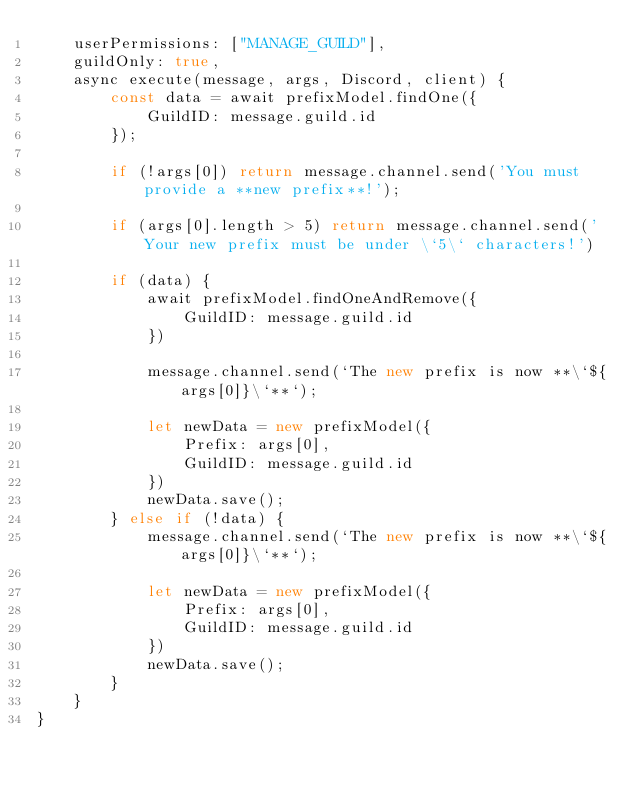Convert code to text. <code><loc_0><loc_0><loc_500><loc_500><_JavaScript_>    userPermissions: ["MANAGE_GUILD"],
    guildOnly: true,
    async execute(message, args, Discord, client) {
        const data = await prefixModel.findOne({
            GuildID: message.guild.id
        });
    
        if (!args[0]) return message.channel.send('You must provide a **new prefix**!');
    
        if (args[0].length > 5) return message.channel.send('Your new prefix must be under \`5\` characters!')
    
        if (data) {
            await prefixModel.findOneAndRemove({
                GuildID: message.guild.id
            })
            
            message.channel.send(`The new prefix is now **\`${args[0]}\`**`);
    
            let newData = new prefixModel({
                Prefix: args[0],
                GuildID: message.guild.id
            })
            newData.save();
        } else if (!data) {
            message.channel.send(`The new prefix is now **\`${args[0]}\`**`);
    
            let newData = new prefixModel({
                Prefix: args[0],
                GuildID: message.guild.id
            })
            newData.save();
        }
    }
}</code> 